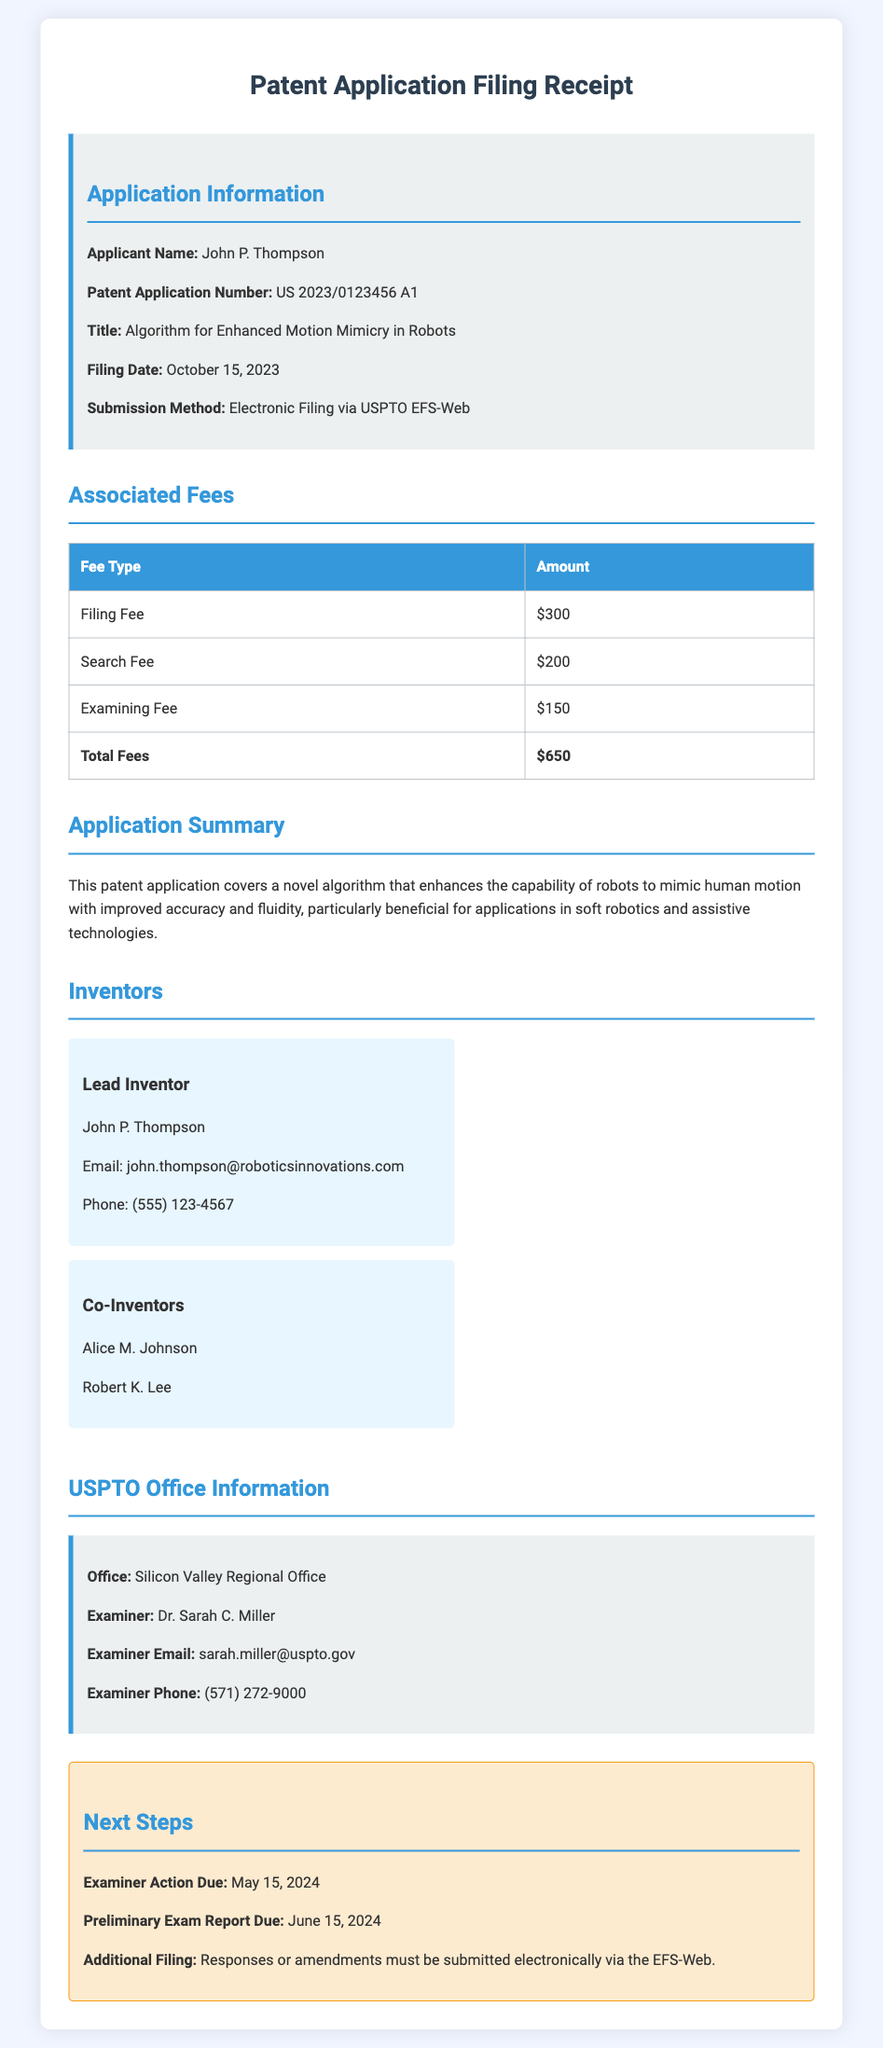What is the applicant's name? The applicant's name is explicitly stated in the document.
Answer: John P. Thompson What is the patent application number? The document provides a unique patent application number for reference.
Answer: US 2023/0123456 A1 What is the filing date? The filing date indicates when the application was submitted, as per the information presented.
Answer: October 15, 2023 What is the total amount of fees? The total fees are computed as the sum of the individual fees listed in the document.
Answer: $650 What is the title of the patent application? The title describes the focus of the patent application in the document.
Answer: Algorithm for Enhanced Motion Mimicry in Robots Who is the lead inventor? The document lists the lead inventor clearly under the inventors section.
Answer: John P. Thompson What is the examiner's name? The examiner's name is specified in the USPTO Office Information section of the document.
Answer: Dr. Sarah C. Miller When is the examiner action due? The deadline for action from the examiner is mentioned under the next steps section.
Answer: May 15, 2024 What method was used for submission? The submission method indicates how the application was filed, which is outlined in the document.
Answer: Electronic Filing via USPTO EFS-Web 